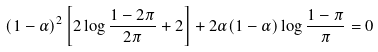<formula> <loc_0><loc_0><loc_500><loc_500>( 1 - \alpha ) ^ { 2 } \left [ 2 \log \frac { 1 - 2 \pi } { 2 \pi } + 2 \right ] + 2 \alpha ( 1 - \alpha ) \log \frac { 1 - \pi } { \pi } = 0</formula> 